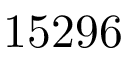Convert formula to latex. <formula><loc_0><loc_0><loc_500><loc_500>1 5 2 9 6</formula> 